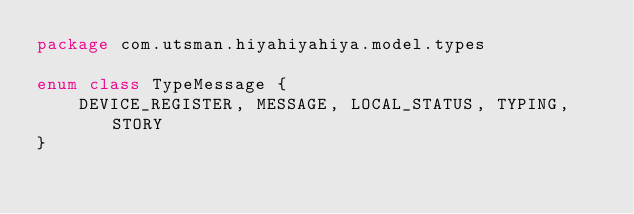Convert code to text. <code><loc_0><loc_0><loc_500><loc_500><_Kotlin_>package com.utsman.hiyahiyahiya.model.types

enum class TypeMessage {
    DEVICE_REGISTER, MESSAGE, LOCAL_STATUS, TYPING, STORY
}</code> 